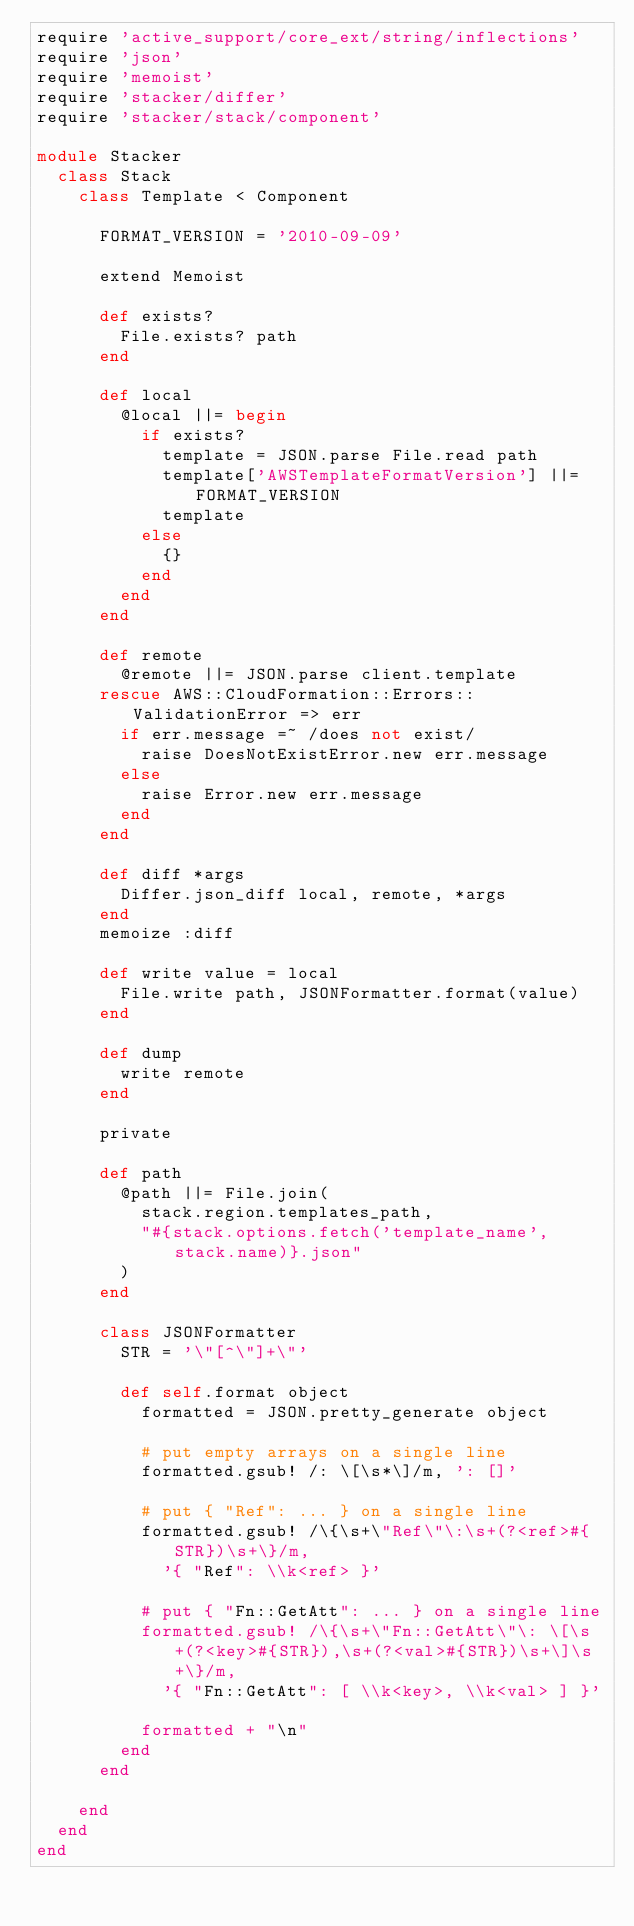<code> <loc_0><loc_0><loc_500><loc_500><_Ruby_>require 'active_support/core_ext/string/inflections'
require 'json'
require 'memoist'
require 'stacker/differ'
require 'stacker/stack/component'

module Stacker
  class Stack
    class Template < Component

      FORMAT_VERSION = '2010-09-09'

      extend Memoist

      def exists?
        File.exists? path
      end

      def local
        @local ||= begin
          if exists?
            template = JSON.parse File.read path
            template['AWSTemplateFormatVersion'] ||= FORMAT_VERSION
            template
          else
            {}
          end
        end
      end

      def remote
        @remote ||= JSON.parse client.template
      rescue AWS::CloudFormation::Errors::ValidationError => err
        if err.message =~ /does not exist/
          raise DoesNotExistError.new err.message
        else
          raise Error.new err.message
        end
      end

      def diff *args
        Differ.json_diff local, remote, *args
      end
      memoize :diff

      def write value = local
        File.write path, JSONFormatter.format(value)
      end

      def dump
        write remote
      end

      private

      def path
        @path ||= File.join(
          stack.region.templates_path,
          "#{stack.options.fetch('template_name', stack.name)}.json"
        )
      end

      class JSONFormatter
        STR = '\"[^\"]+\"'

        def self.format object
          formatted = JSON.pretty_generate object

          # put empty arrays on a single line
          formatted.gsub! /: \[\s*\]/m, ': []'

          # put { "Ref": ... } on a single line
          formatted.gsub! /\{\s+\"Ref\"\:\s+(?<ref>#{STR})\s+\}/m,
            '{ "Ref": \\k<ref> }'

          # put { "Fn::GetAtt": ... } on a single line
          formatted.gsub! /\{\s+\"Fn::GetAtt\"\: \[\s+(?<key>#{STR}),\s+(?<val>#{STR})\s+\]\s+\}/m,
            '{ "Fn::GetAtt": [ \\k<key>, \\k<val> ] }'

          formatted + "\n"
        end
      end

    end
  end
end
</code> 